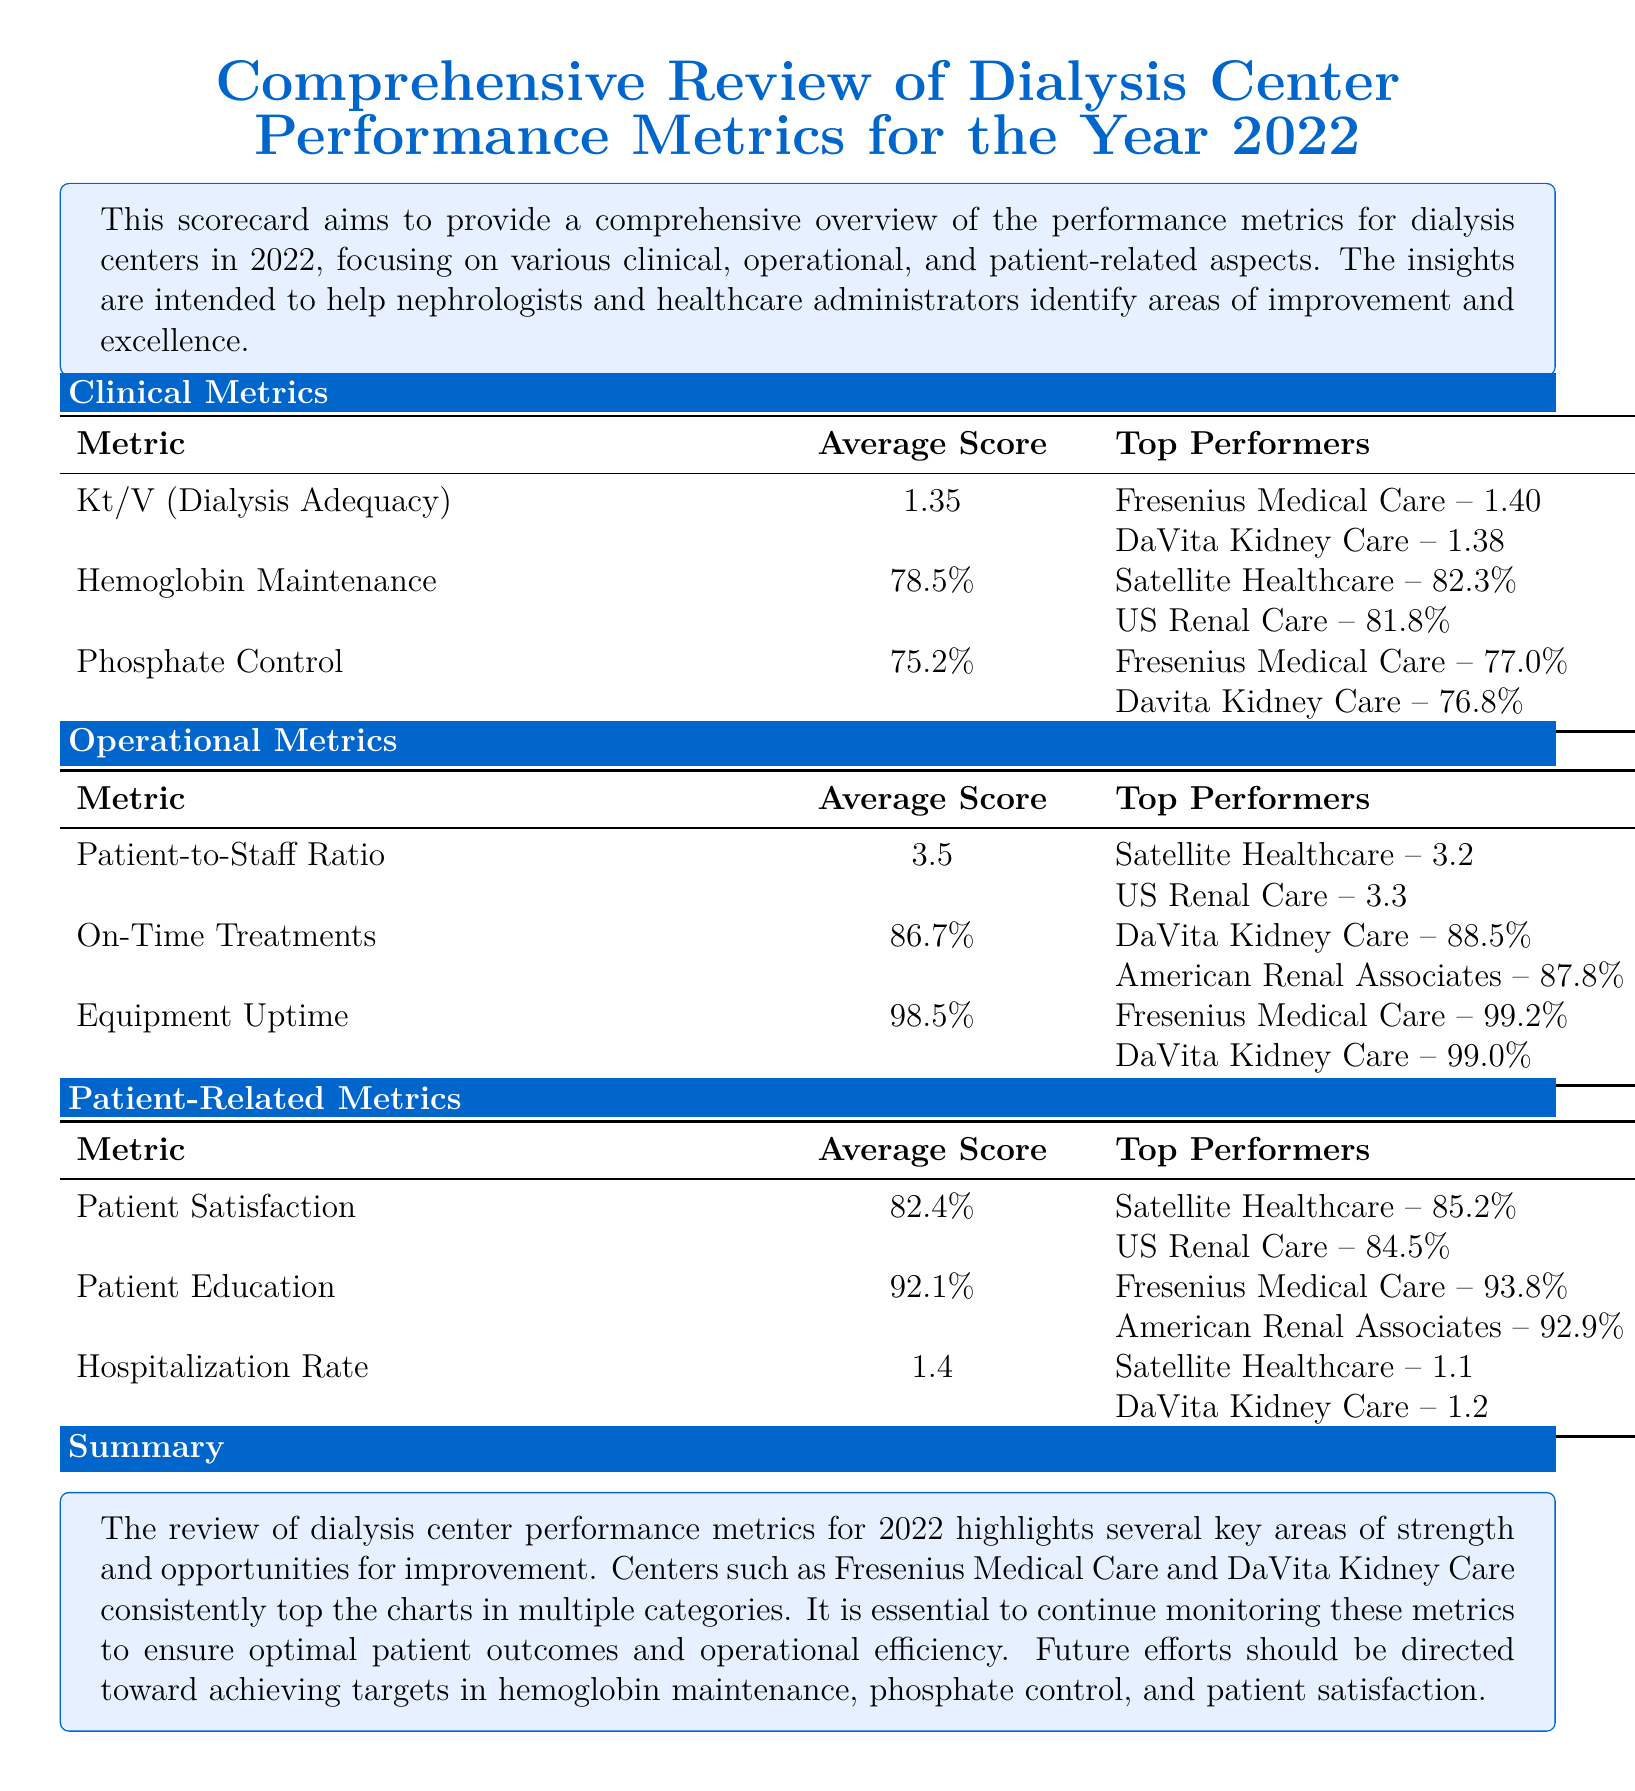What is the average Kt/V for dialysis adequacy? The average Kt/V for dialysis adequacy is provided in the Clinical Metrics section as 1.35.
Answer: 1.35 Which center had the highest hemoglobin maintenance percentage? The center with the highest hemoglobin maintenance percentage is mentioned in the Clinical Metrics section as Satellite Healthcare with 82.3%.
Answer: Satellite Healthcare What is the average patient satisfaction percentage? The average patient satisfaction percentage is mentioned under Patient-Related Metrics as 82.4%.
Answer: 82.4% What is the top performer's equipment uptime percentage? The top performer's equipment uptime percentage can be found in the Operational Metrics section as 99.2% for Fresenius Medical Care.
Answer: 99.2% What is the hospitalization rate for Satellite Healthcare? The hospitalization rate for Satellite Healthcare is listed under Patient-Related Metrics as 1.1.
Answer: 1.1 Which metric shows the best performance in the document summary? The document summary highlights the need for improvement in hemoglobin maintenance, phosphate control, and patient satisfaction metrics.
Answer: Hemoglobin maintenance How many top performers are listed for phosphate control? The document lists two top performers for phosphate control in the Clinical Metrics section.
Answer: Two What was the focus of the scorecard? The focus of the scorecard is described in the introduction as providing a comprehensive overview of performance metrics for dialysis centers.
Answer: Performance metrics What does the average score for on-time treatments indicate? The average score for on-time treatments is indicated as 86.7% in the Operational Metrics section.
Answer: 86.7% 